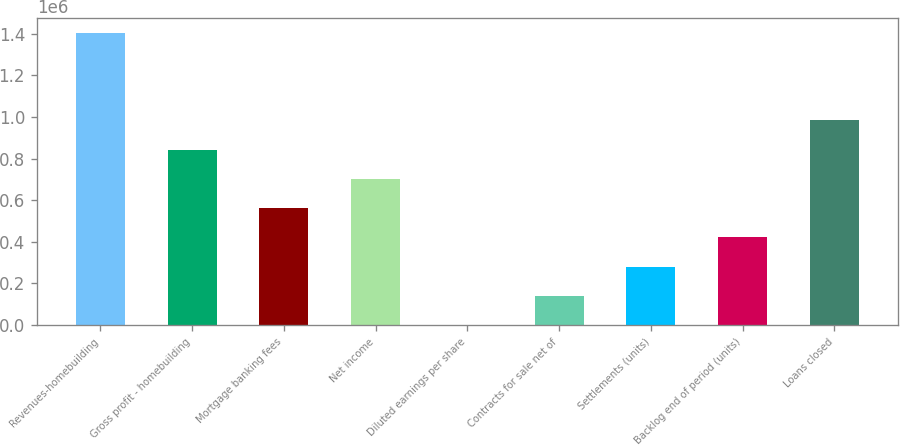Convert chart. <chart><loc_0><loc_0><loc_500><loc_500><bar_chart><fcel>Revenues-homebuilding<fcel>Gross profit - homebuilding<fcel>Mortgage banking fees<fcel>Net income<fcel>Diluted earnings per share<fcel>Contracts for sale net of<fcel>Settlements (units)<fcel>Backlog end of period (units)<fcel>Loans closed<nl><fcel>1.40547e+06<fcel>843284<fcel>562193<fcel>702739<fcel>11.72<fcel>140557<fcel>281103<fcel>421648<fcel>983830<nl></chart> 